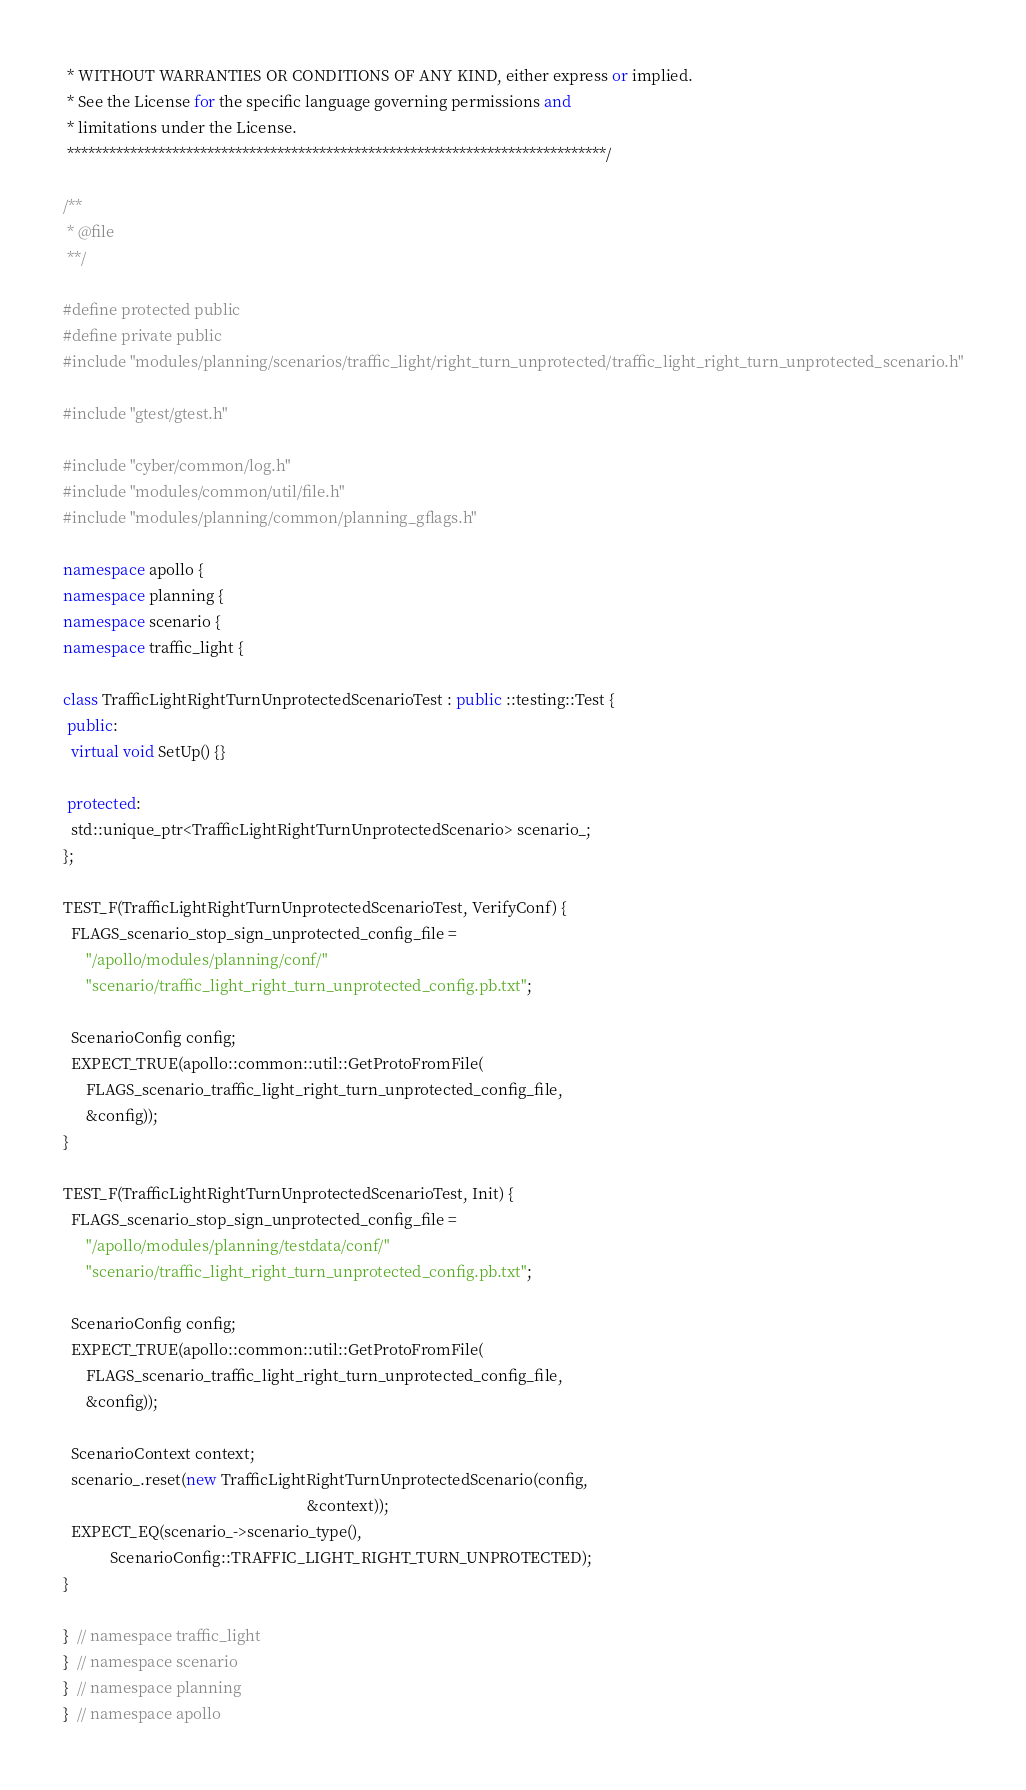<code> <loc_0><loc_0><loc_500><loc_500><_C++_> * WITHOUT WARRANTIES OR CONDITIONS OF ANY KIND, either express or implied.
 * See the License for the specific language governing permissions and
 * limitations under the License.
 *****************************************************************************/

/**
 * @file
 **/

#define protected public
#define private public
#include "modules/planning/scenarios/traffic_light/right_turn_unprotected/traffic_light_right_turn_unprotected_scenario.h"

#include "gtest/gtest.h"

#include "cyber/common/log.h"
#include "modules/common/util/file.h"
#include "modules/planning/common/planning_gflags.h"

namespace apollo {
namespace planning {
namespace scenario {
namespace traffic_light {

class TrafficLightRightTurnUnprotectedScenarioTest : public ::testing::Test {
 public:
  virtual void SetUp() {}

 protected:
  std::unique_ptr<TrafficLightRightTurnUnprotectedScenario> scenario_;
};

TEST_F(TrafficLightRightTurnUnprotectedScenarioTest, VerifyConf) {
  FLAGS_scenario_stop_sign_unprotected_config_file =
      "/apollo/modules/planning/conf/"
      "scenario/traffic_light_right_turn_unprotected_config.pb.txt";

  ScenarioConfig config;
  EXPECT_TRUE(apollo::common::util::GetProtoFromFile(
      FLAGS_scenario_traffic_light_right_turn_unprotected_config_file,
      &config));
}

TEST_F(TrafficLightRightTurnUnprotectedScenarioTest, Init) {
  FLAGS_scenario_stop_sign_unprotected_config_file =
      "/apollo/modules/planning/testdata/conf/"
      "scenario/traffic_light_right_turn_unprotected_config.pb.txt";

  ScenarioConfig config;
  EXPECT_TRUE(apollo::common::util::GetProtoFromFile(
      FLAGS_scenario_traffic_light_right_turn_unprotected_config_file,
      &config));

  ScenarioContext context;
  scenario_.reset(new TrafficLightRightTurnUnprotectedScenario(config,
                                                               &context));
  EXPECT_EQ(scenario_->scenario_type(),
            ScenarioConfig::TRAFFIC_LIGHT_RIGHT_TURN_UNPROTECTED);
}

}  // namespace traffic_light
}  // namespace scenario
}  // namespace planning
}  // namespace apollo
</code> 